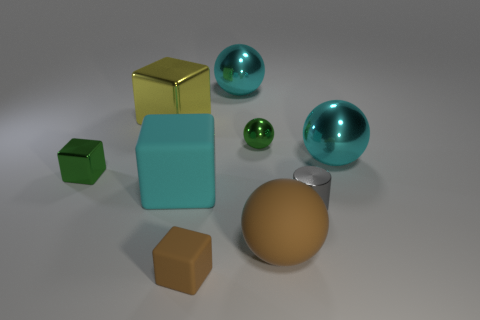Subtract all green spheres. How many spheres are left? 3 Subtract all cyan rubber blocks. How many blocks are left? 3 Subtract all cyan cylinders. How many cyan spheres are left? 2 Subtract 1 spheres. How many spheres are left? 3 Add 1 yellow metallic cubes. How many objects exist? 10 Subtract all blue blocks. Subtract all red spheres. How many blocks are left? 4 Subtract all spheres. How many objects are left? 5 Add 8 green metal spheres. How many green metal spheres exist? 9 Subtract 1 cyan spheres. How many objects are left? 8 Subtract all cyan blocks. Subtract all cyan shiny objects. How many objects are left? 6 